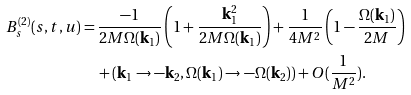<formula> <loc_0><loc_0><loc_500><loc_500>B _ { s } ^ { ( 2 ) } ( s , t , u ) = & \, \frac { - 1 } { 2 M \Omega ( \mathbf k _ { 1 } ) } \left ( 1 + \frac { \mathbf k _ { 1 } ^ { 2 } } { 2 M \Omega ( \mathbf k _ { 1 } ) } \right ) + \frac { 1 } { 4 M ^ { 2 } } \left ( 1 - \frac { \Omega ( \mathbf k _ { 1 } ) } { 2 M } \right ) \\ & \, + ( \mathbf k _ { 1 } \rightarrow - \mathbf k _ { 2 } , \Omega ( \mathbf k _ { 1 } ) \rightarrow - \Omega ( \mathbf k _ { 2 } ) ) + O ( \frac { 1 } { M ^ { 2 } } ) .</formula> 